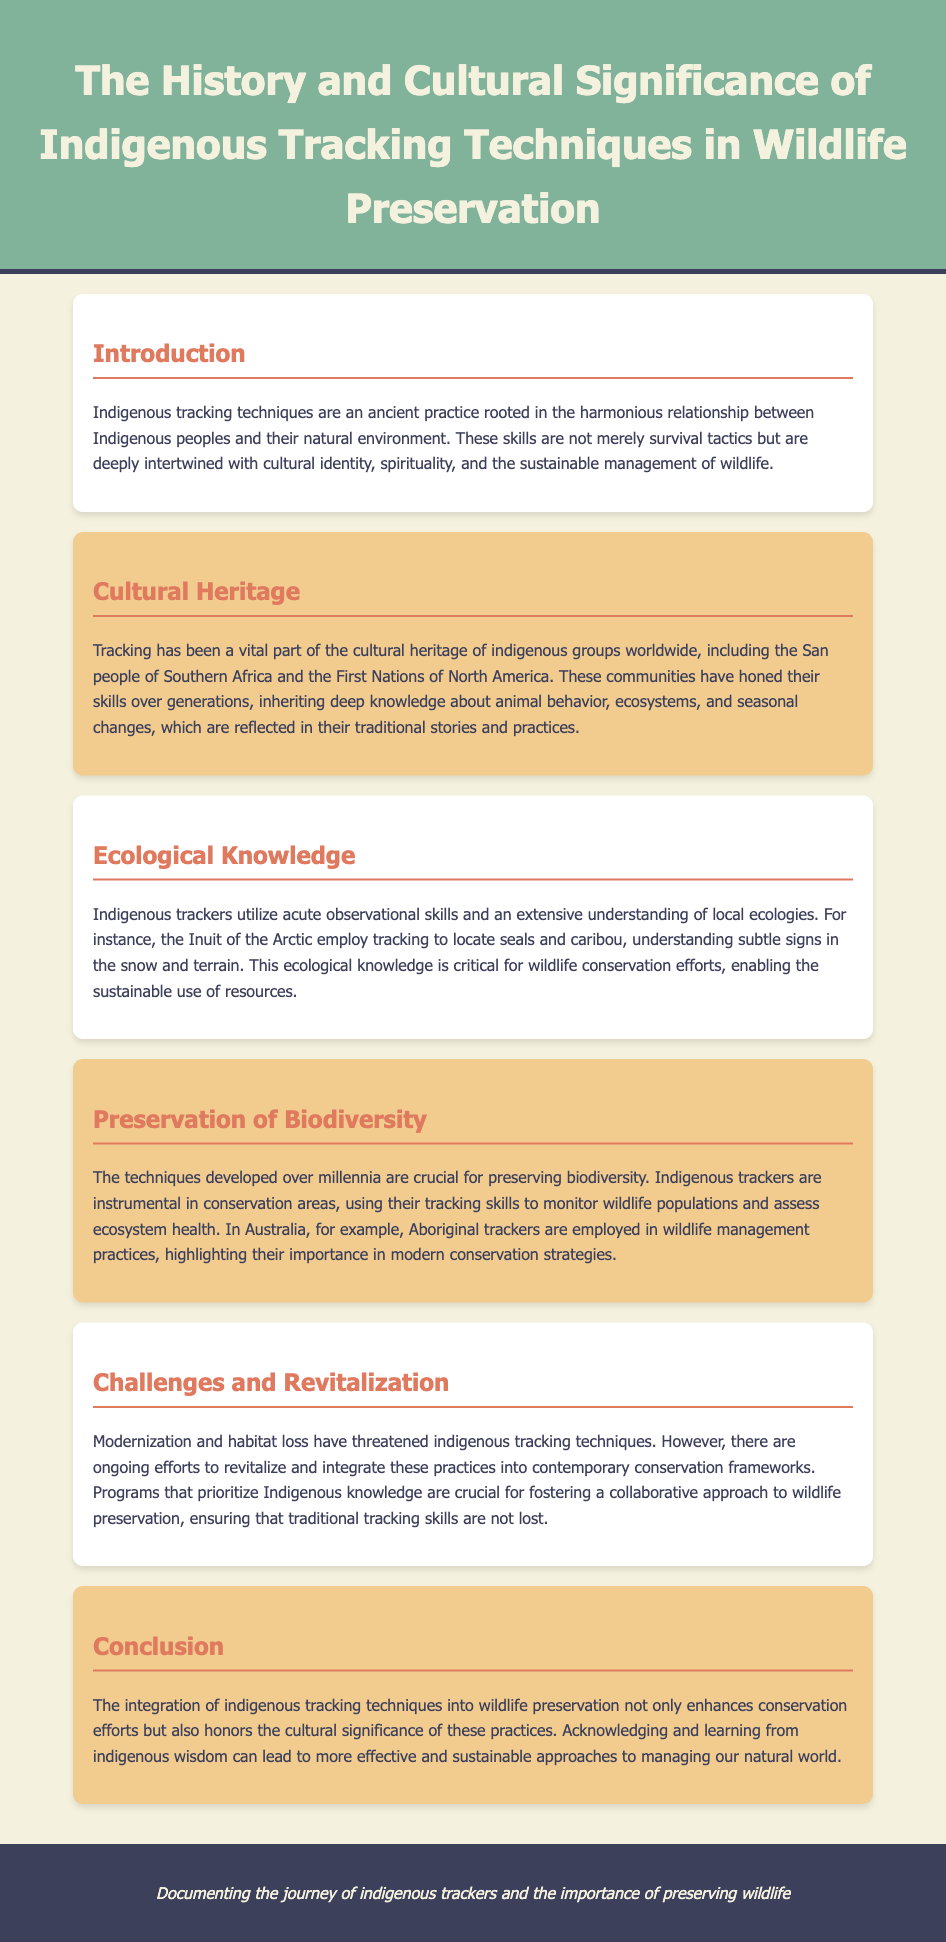What are indigenous tracking techniques rooted in? Indigenous tracking techniques are rooted in the harmonious relationship between Indigenous peoples and their natural environment.
Answer: Harmonious relationship Which indigenous groups are mentioned in relation to cultural heritage? The document mentions the San people of Southern Africa and the First Nations of North America regarding their cultural heritage in tracking.
Answer: San people and First Nations What skills are crucial for indigenous trackers? Indigenous trackers utilize acute observational skills and an extensive understanding of local ecologies.
Answer: Observational skills and ecological understanding Name one example of indigenous trackers employed in wildlife management. An example given in the document is that Aboriginal trackers are employed in wildlife management practices in Australia.
Answer: Aboriginal trackers What challenges threaten indigenous tracking techniques? Modernization and habitat loss are mentioned as challenges that threaten indigenous tracking techniques.
Answer: Modernization and habitat loss How does indigenous tracking contribute to biodiversity? Indigenous tracking contributes to biodiversity by monitoring wildlife populations and assessing ecosystem health.
Answer: Monitoring wildlife populations What approach is crucial for revitalizing indigenous tracking techniques? The document states that programs prioritizing Indigenous knowledge are crucial for revitalizing these practices.
Answer: Programs prioritizing Indigenous knowledge What is the concluding statement regarding indigenous tracking techniques and wildlife preservation? The conclusion highlights the importance of integrating indigenous tracking techniques for more effective conservation approaches.
Answer: Integration for effective conservation 